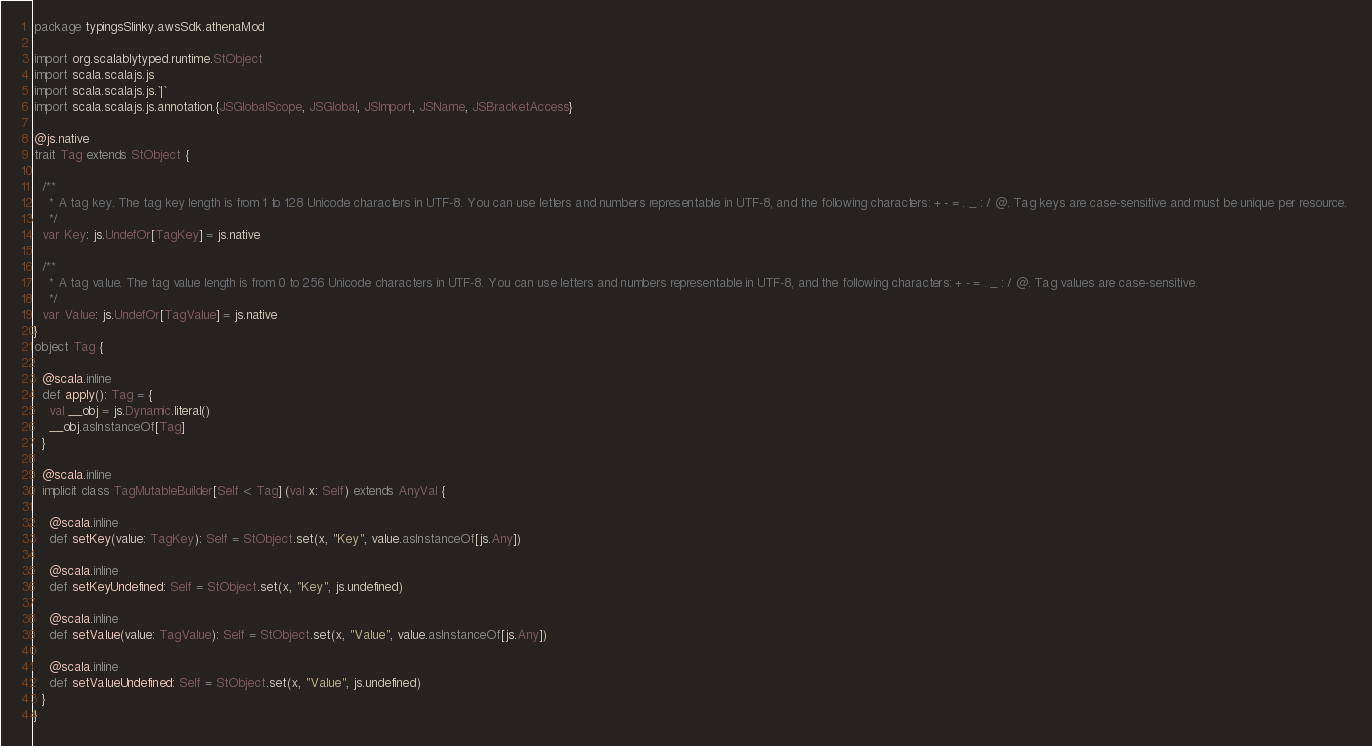<code> <loc_0><loc_0><loc_500><loc_500><_Scala_>package typingsSlinky.awsSdk.athenaMod

import org.scalablytyped.runtime.StObject
import scala.scalajs.js
import scala.scalajs.js.`|`
import scala.scalajs.js.annotation.{JSGlobalScope, JSGlobal, JSImport, JSName, JSBracketAccess}

@js.native
trait Tag extends StObject {
  
  /**
    * A tag key. The tag key length is from 1 to 128 Unicode characters in UTF-8. You can use letters and numbers representable in UTF-8, and the following characters: + - = . _ : / @. Tag keys are case-sensitive and must be unique per resource. 
    */
  var Key: js.UndefOr[TagKey] = js.native
  
  /**
    * A tag value. The tag value length is from 0 to 256 Unicode characters in UTF-8. You can use letters and numbers representable in UTF-8, and the following characters: + - = . _ : / @. Tag values are case-sensitive. 
    */
  var Value: js.UndefOr[TagValue] = js.native
}
object Tag {
  
  @scala.inline
  def apply(): Tag = {
    val __obj = js.Dynamic.literal()
    __obj.asInstanceOf[Tag]
  }
  
  @scala.inline
  implicit class TagMutableBuilder[Self <: Tag] (val x: Self) extends AnyVal {
    
    @scala.inline
    def setKey(value: TagKey): Self = StObject.set(x, "Key", value.asInstanceOf[js.Any])
    
    @scala.inline
    def setKeyUndefined: Self = StObject.set(x, "Key", js.undefined)
    
    @scala.inline
    def setValue(value: TagValue): Self = StObject.set(x, "Value", value.asInstanceOf[js.Any])
    
    @scala.inline
    def setValueUndefined: Self = StObject.set(x, "Value", js.undefined)
  }
}
</code> 